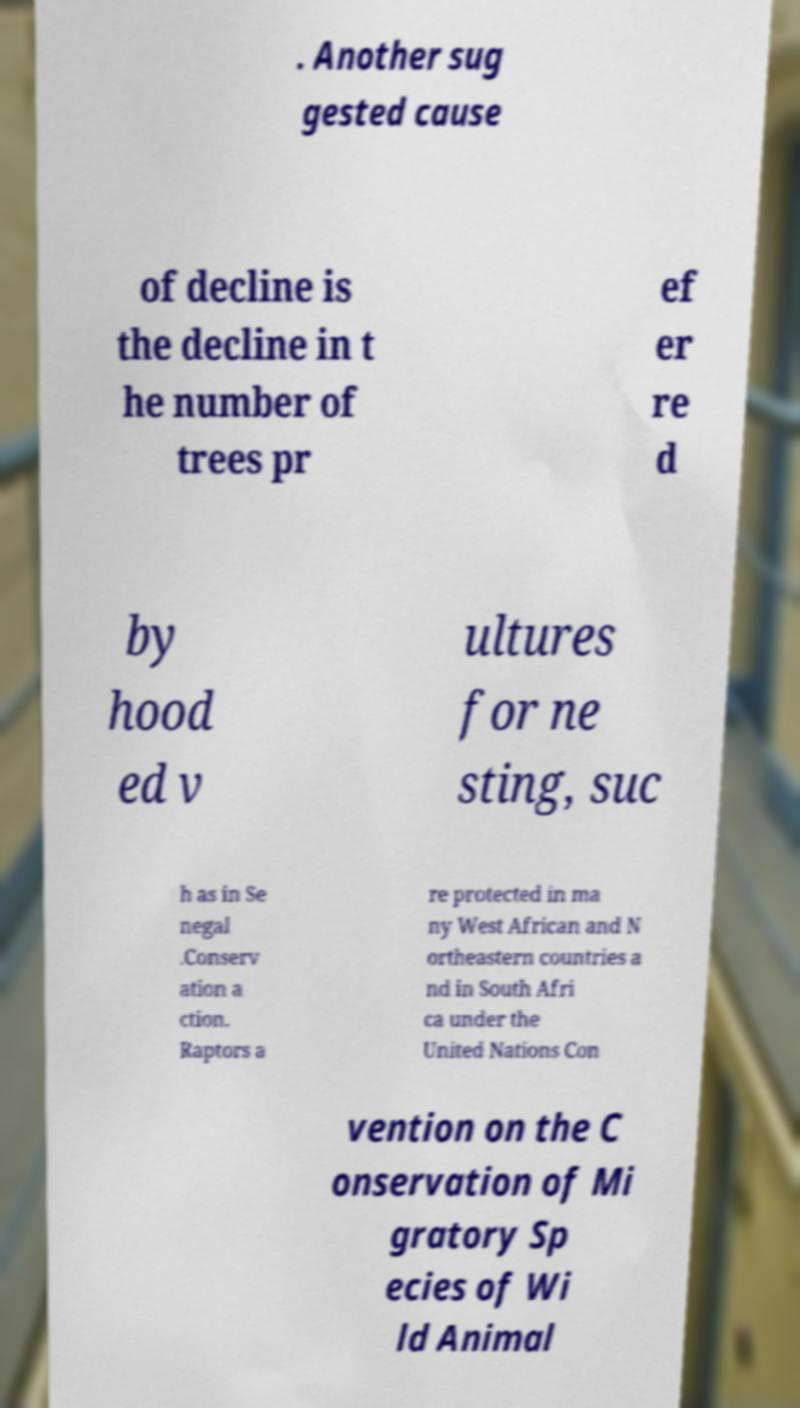Please identify and transcribe the text found in this image. . Another sug gested cause of decline is the decline in t he number of trees pr ef er re d by hood ed v ultures for ne sting, suc h as in Se negal .Conserv ation a ction. Raptors a re protected in ma ny West African and N ortheastern countries a nd in South Afri ca under the United Nations Con vention on the C onservation of Mi gratory Sp ecies of Wi ld Animal 